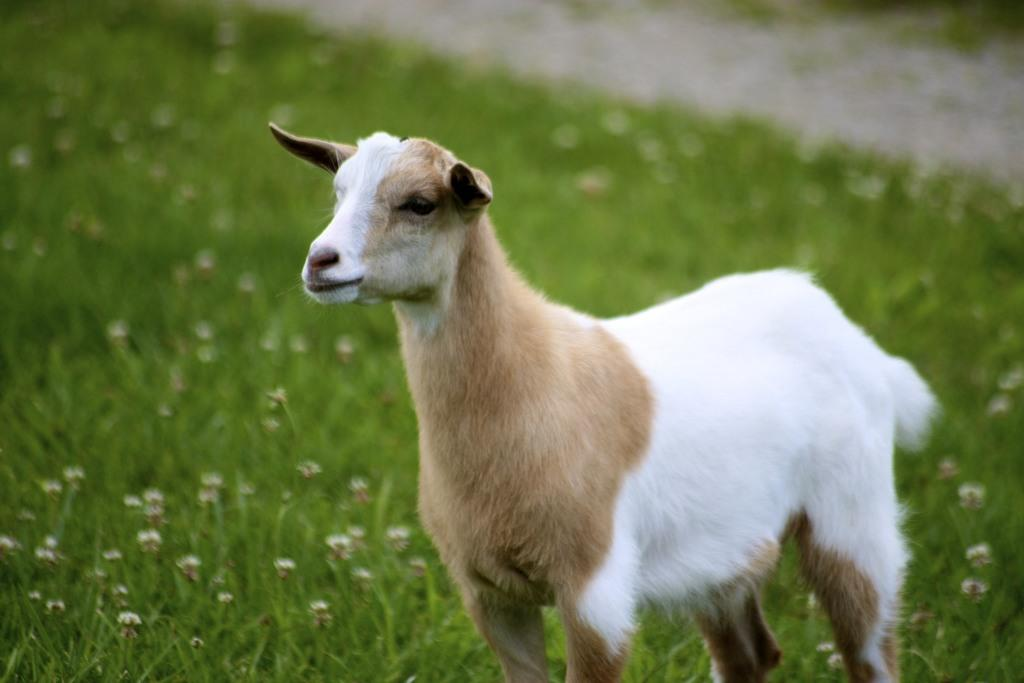What type of surface covers the ground in the image? The ground in the image is covered with grass. What animal can be seen in the image? There is a grey and white colored goat in the image. Where is the goat positioned in the image? The goat is standing on the grass ground. Where is the shelf located in the image? There is no shelf present in the image. What type of brush can be seen in the goat's hand in the image? There is no brush or any object in the goat's hand in the image. 